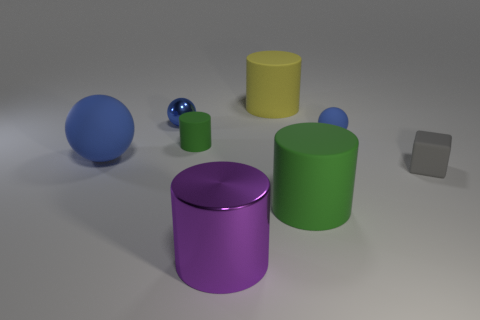How many blue balls must be subtracted to get 1 blue balls? 2 Add 1 large spheres. How many objects exist? 9 Subtract all tiny green rubber cylinders. How many cylinders are left? 3 Subtract all red balls. How many green cylinders are left? 2 Subtract all balls. How many objects are left? 5 Subtract all green cylinders. How many cylinders are left? 2 Subtract 1 cylinders. How many cylinders are left? 3 Subtract 1 yellow cylinders. How many objects are left? 7 Subtract all cyan spheres. Subtract all blue cylinders. How many spheres are left? 3 Subtract all spheres. Subtract all small rubber objects. How many objects are left? 2 